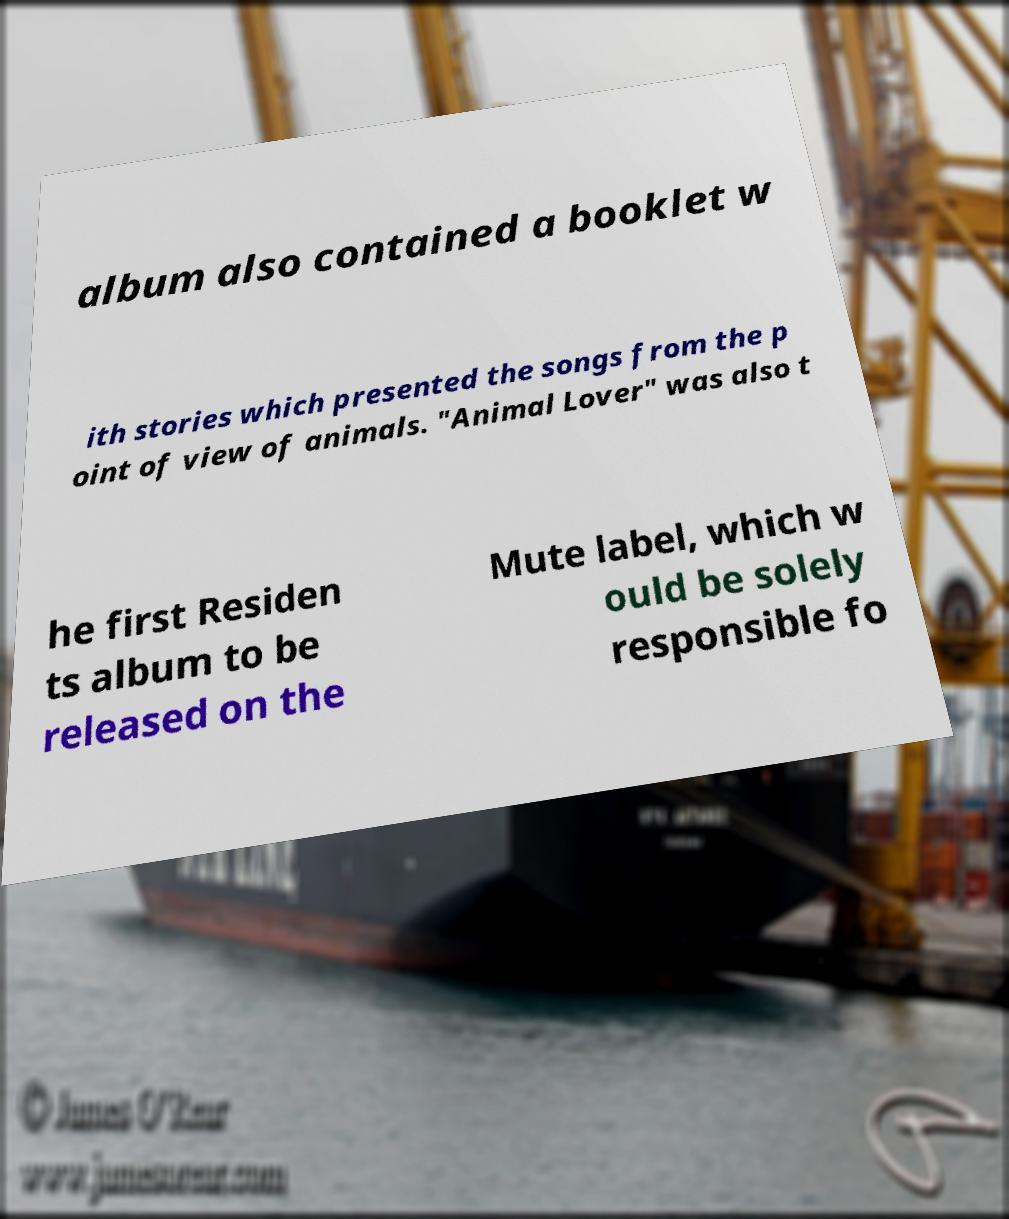Please identify and transcribe the text found in this image. album also contained a booklet w ith stories which presented the songs from the p oint of view of animals. "Animal Lover" was also t he first Residen ts album to be released on the Mute label, which w ould be solely responsible fo 